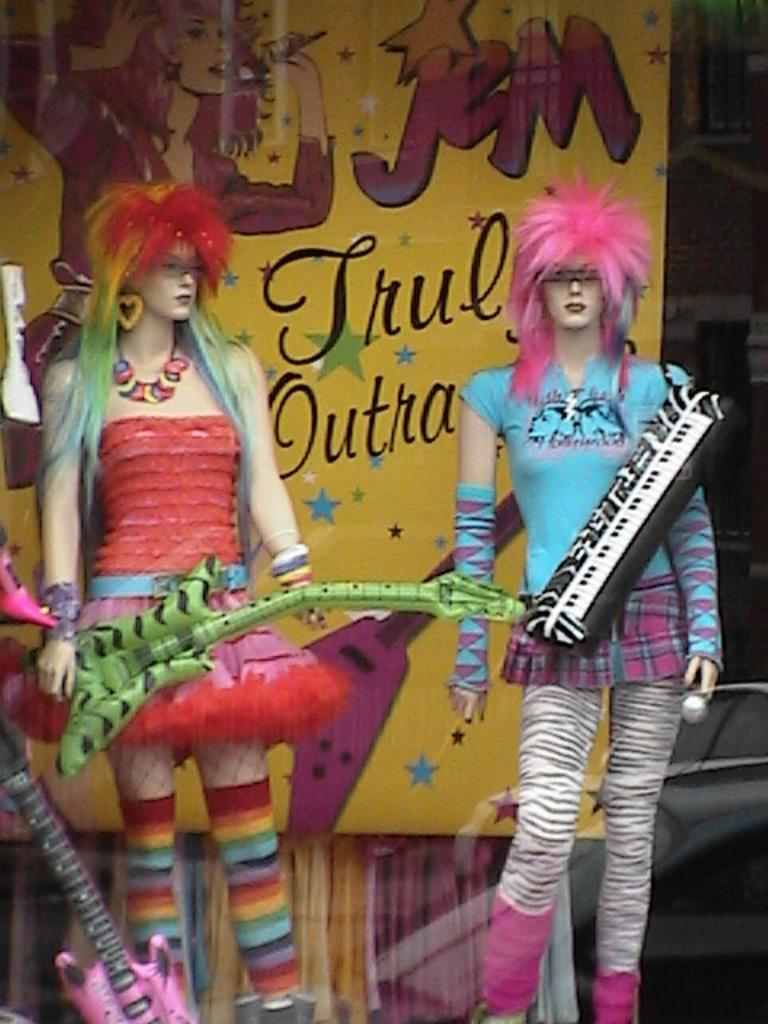How many dolls are present in the image? There are two dolls standing in the image. What can be seen in the background of the image? There is a banner visible in the background. What object is located on the left side of the image? There is a guitar on the left side of the image. What type of breakfast is being served on the guitar in the image? There is no breakfast or any food item present on the guitar in the image. 